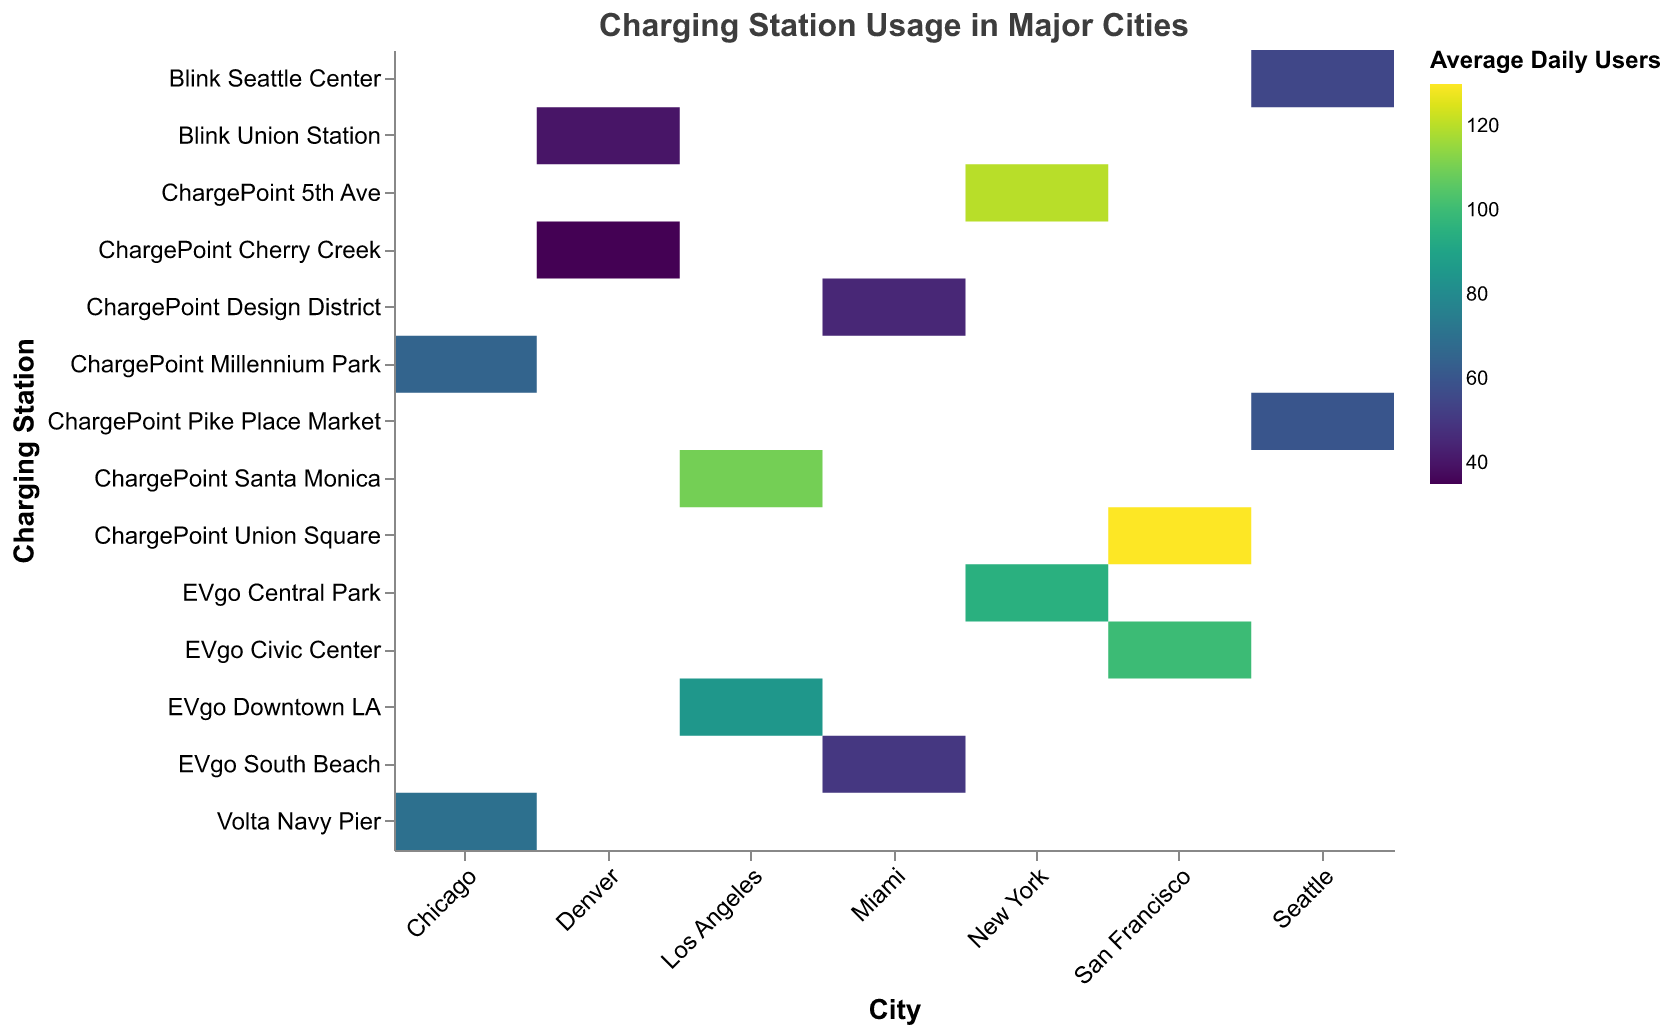What's the title of the heatmap? The title of the heatmap is written at the top of the figure and it summarizes the overall data being depicted. In this case, it reads "Charging Station Usage in Major Cities".
Answer: Charging Station Usage in Major Cities Which city appears to have the highest average daily users for a charging station? By looking at the heatmap and identifying the darkest color tone, it indicates the highest value which belongs to the city San Francisco at the charging station ChargePoint Union Square.
Answer: San Francisco How many cities are represented in the heatmap? Each city is listed along the x-axis of the heatmap. There are 7 unique cities represented: New York, Los Angeles, Chicago, San Francisco, Seattle, Miami, Denver.
Answer: 7 What is the average daily user count at ChargePoint Millennium Park in Chicago? By locating ChargePoint Millennium Park on the y-axis and following it horizontally to where it intersects with Chicago on the x-axis, the color intensity and tooltip indicate the average daily users which is 65.
Answer: 65 Which charging station in Miami has a higher average daily users count, EVgo South Beach or ChargePoint Design District? By comparing the color intensity for both charging stations in Miami, EVgo South Beach with 50 users is higher than ChargePoint Design District with 45 users.
Answer: EVgo South Beach What's the difference in average daily users between the highest and the lowest used charging stations? The highest daily users are at ChargePoint Union Square in San Francisco with 130 users and the lowest is at ChargePoint Cherry Creek in Denver with 35 users. The difference is 130 - 35 = 95.
Answer: 95 Which charging station has similar usage patterns in Seattle? By checking the color intensities for Seattle, Blink Seattle Center has 55 average daily users and ChargePoint Pike Place Market has 60, which are close in value.
Answer: Blink Seattle Center and ChargePoint Pike Place Market What is the combined average daily user count for the charging stations in Los Angeles? Summing the average daily users for ChargePoint Santa Monica (110) and EVgo Downtown LA (85), we get 110 + 85 = 195.
Answer: 195 In which city is the usage pattern of charging stations spread more evenly? Evaluating the color tones for each city's charging stations, Chicago’s Volta Navy Pier (70) and ChargePoint Millennium Park (65) are close in usage, indicating more evenly spread usage patterns compared to other cities with a larger variance.
Answer: Chicago 